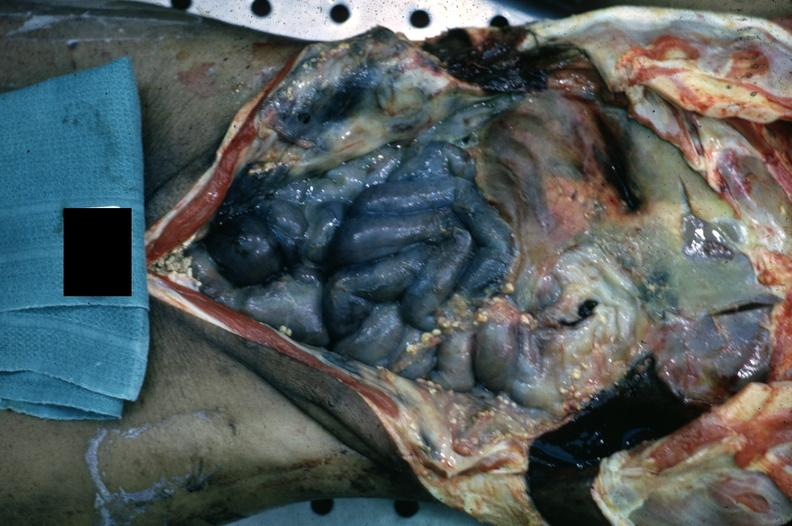what is present?
Answer the question using a single word or phrase. Fibrinous peritonitis 